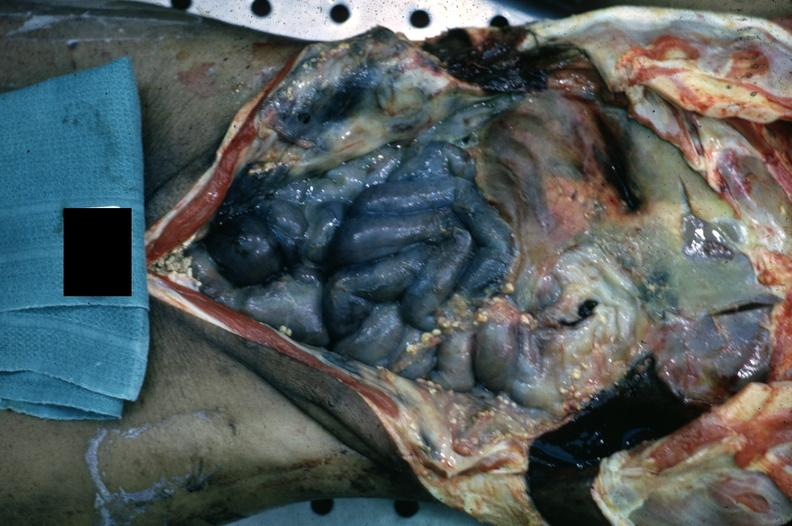what is present?
Answer the question using a single word or phrase. Fibrinous peritonitis 